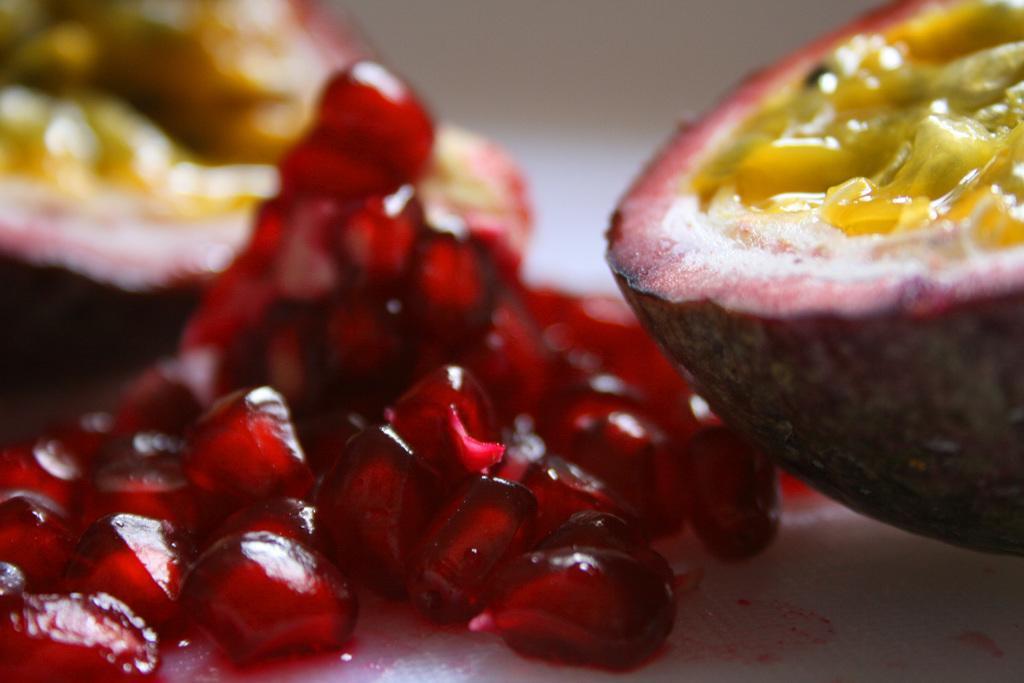Can you describe this image briefly? In this image we can see group of fruits. 